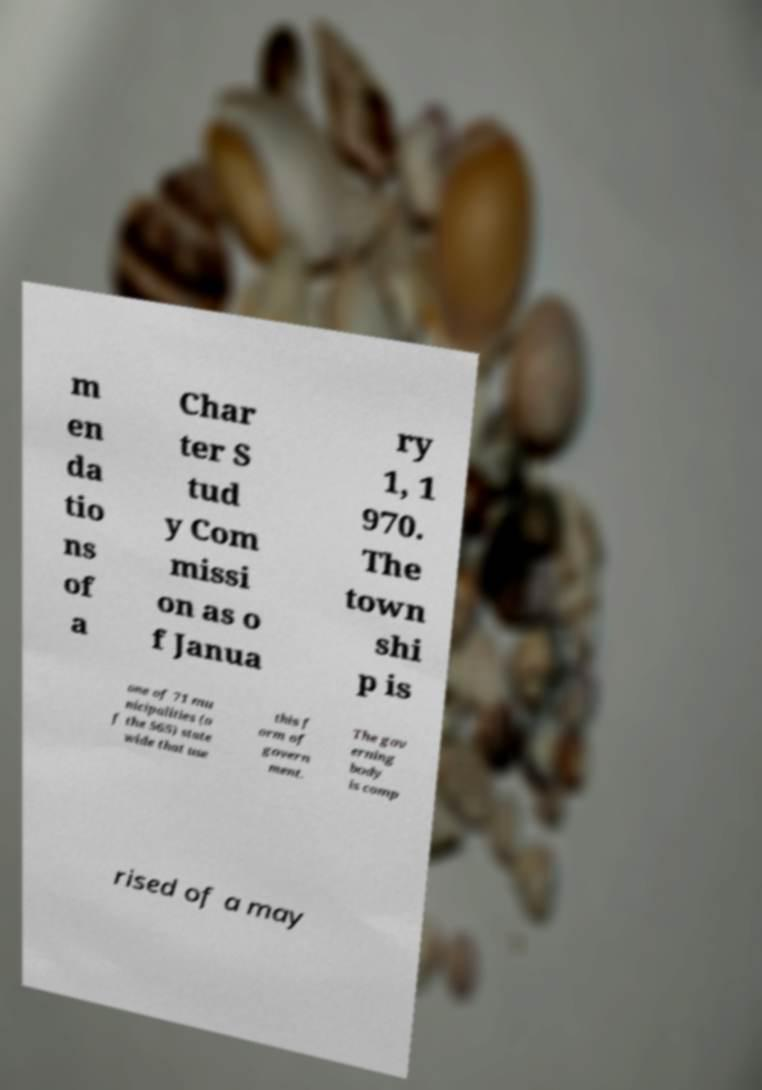There's text embedded in this image that I need extracted. Can you transcribe it verbatim? m en da tio ns of a Char ter S tud y Com missi on as o f Janua ry 1, 1 970. The town shi p is one of 71 mu nicipalities (o f the 565) state wide that use this f orm of govern ment. The gov erning body is comp rised of a may 